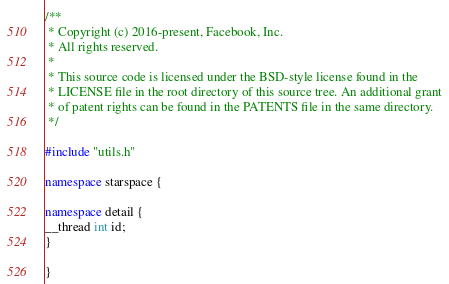Convert code to text. <code><loc_0><loc_0><loc_500><loc_500><_C++_>/**
 * Copyright (c) 2016-present, Facebook, Inc.
 * All rights reserved.
 *
 * This source code is licensed under the BSD-style license found in the
 * LICENSE file in the root directory of this source tree. An additional grant
 * of patent rights can be found in the PATENTS file in the same directory.
 */

#include "utils.h"

namespace starspace {

namespace detail {
__thread int id;
}

}
</code> 